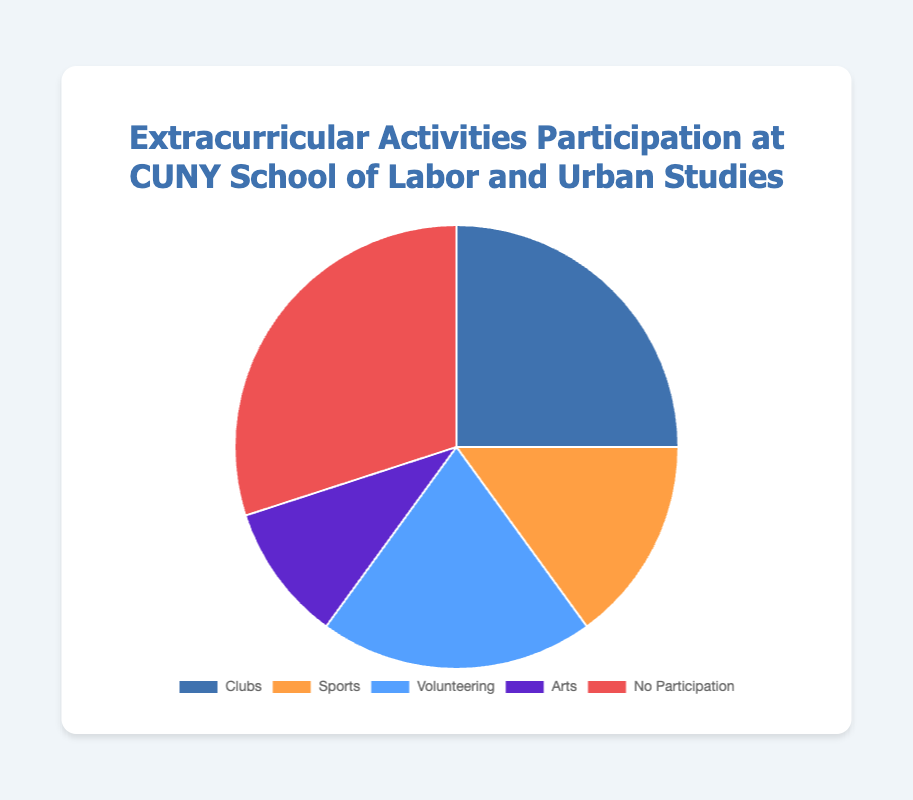What percentage of students participate in clubs? Look at the pie chart segment labeled "Clubs" and its value is 25%.
Answer: 25% Which activity has the highest participation? Identify the segment with the largest size/value on the pie chart, which is "No Participation" at 30%.
Answer: No Participation Which is higher, the percentage of students participating in sports or those participating in arts? Compare the values for "Sports" (15%) and "Arts" (10%). 15% is greater than 10%.
Answer: Sports What is the combined percentage of students participating in volunteering and arts? Add the percentages for "Volunteering" (20%) and "Arts" (10%). 20% + 10% = 30%.
Answer: 30% How does the percentage of students with no participation compare to those in clubs? Compare the values of "No Participation" (30%) and "Clubs" (25%). 30% is greater than 25%.
Answer: No Participation is higher Which activity has the lowest participation rate? Identify the segment with the smallest size/value on the pie chart, which is "Arts" at 10%.
Answer: Arts Is the percentage of students participating in sports less than those in volunteering? Compare the values for "Sports" (15%) and "Volunteering" (20%). 15% is less than 20%.
Answer: Yes What are the visual attributes of the largest segment in the pie chart? Identify the largest segment which is "No Participation" and describe its visual color, which is red.
Answer: Red Calculate the average percentage of students participating in extracurricular activities (excluding no participation). Combine the percentages for Clubs (25%), Sports (15%), Volunteering (20%), and Arts (10%), then divide by the number of activities: (25% + 15% + 20% + 10%) / 4 = 70% / 4 = 17.5%.
Answer: 17.5% What is the difference between the highest and lowest participation rates? Subtract the percentage of "Arts" (10%) from "No Participation" (30%). 30% - 10% = 20%.
Answer: 20% 